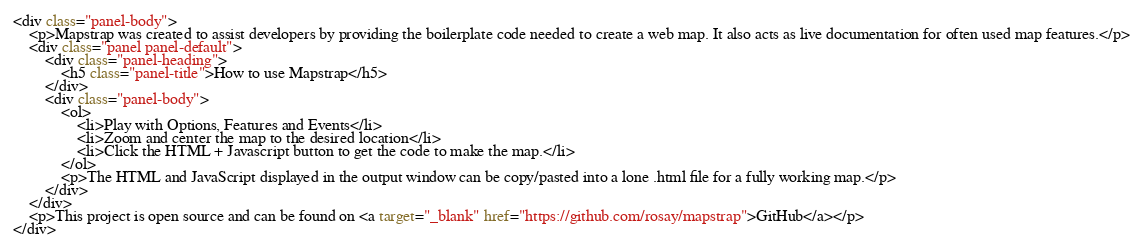Convert code to text. <code><loc_0><loc_0><loc_500><loc_500><_HTML_><div class="panel-body">
    <p>Mapstrap was created to assist developers by providing the boilerplate code needed to create a web map. It also acts as live documentation for often used map features.</p>
    <div class="panel panel-default">
        <div class="panel-heading">
            <h5 class="panel-title">How to use Mapstrap</h5>
        </div>
        <div class="panel-body">
            <ol>
                <li>Play with Options, Features and Events</li>
                <li>Zoom and center the map to the desired location</li>
                <li>Click the HTML + Javascript button to get the code to make the map.</li>
            </ol>
            <p>The HTML and JavaScript displayed in the output window can be copy/pasted into a lone .html file for a fully working map.</p>
        </div>
    </div>
    <p>This project is open source and can be found on <a target="_blank" href="https://github.com/rosay/mapstrap">GitHub</a></p>
</div>
</code> 